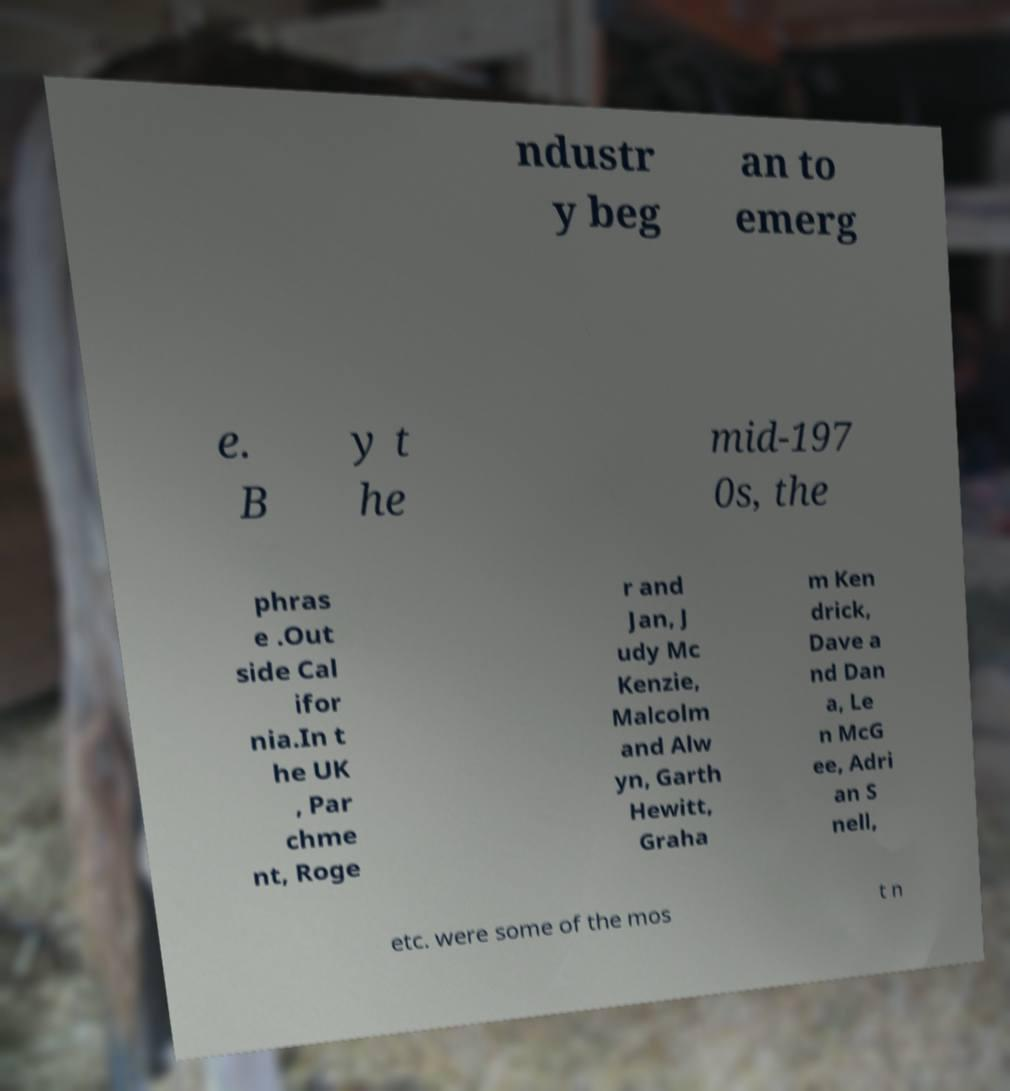Can you accurately transcribe the text from the provided image for me? ndustr y beg an to emerg e. B y t he mid-197 0s, the phras e .Out side Cal ifor nia.In t he UK , Par chme nt, Roge r and Jan, J udy Mc Kenzie, Malcolm and Alw yn, Garth Hewitt, Graha m Ken drick, Dave a nd Dan a, Le n McG ee, Adri an S nell, etc. were some of the mos t n 